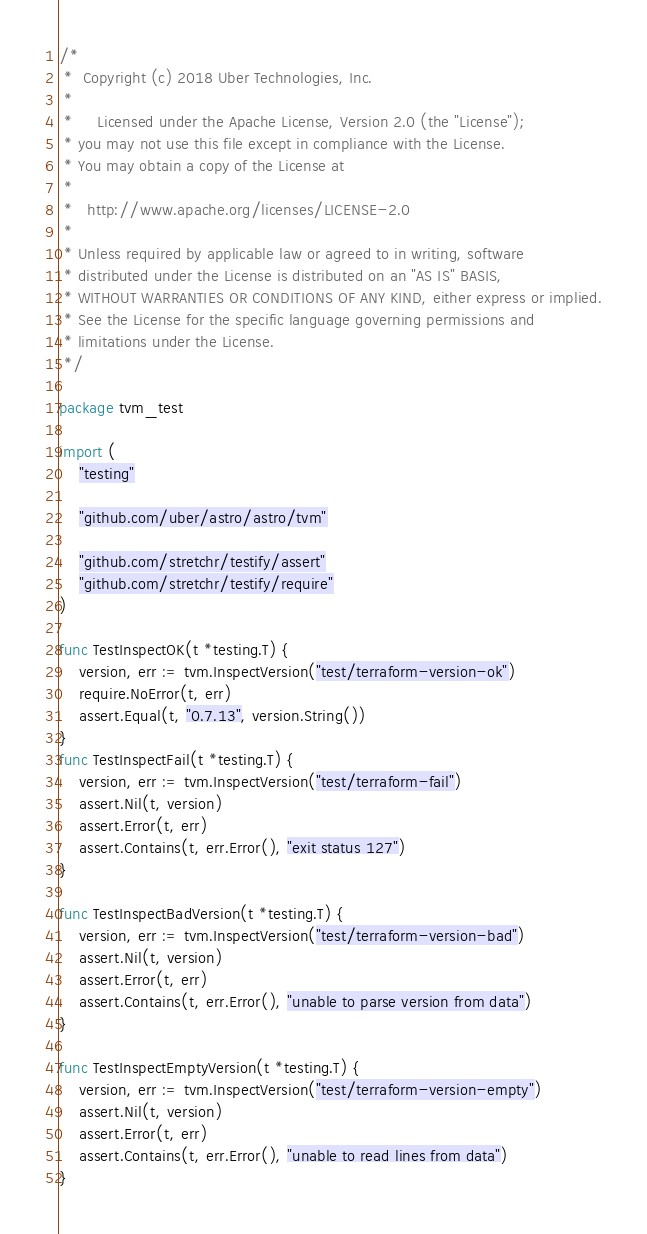<code> <loc_0><loc_0><loc_500><loc_500><_Go_>/*
 *  Copyright (c) 2018 Uber Technologies, Inc.
 *
 *     Licensed under the Apache License, Version 2.0 (the "License");
 * you may not use this file except in compliance with the License.
 * You may obtain a copy of the License at
 *
 *   http://www.apache.org/licenses/LICENSE-2.0
 *
 * Unless required by applicable law or agreed to in writing, software
 * distributed under the License is distributed on an "AS IS" BASIS,
 * WITHOUT WARRANTIES OR CONDITIONS OF ANY KIND, either express or implied.
 * See the License for the specific language governing permissions and
 * limitations under the License.
 */

package tvm_test

import (
	"testing"

	"github.com/uber/astro/astro/tvm"

	"github.com/stretchr/testify/assert"
	"github.com/stretchr/testify/require"
)

func TestInspectOK(t *testing.T) {
	version, err := tvm.InspectVersion("test/terraform-version-ok")
	require.NoError(t, err)
	assert.Equal(t, "0.7.13", version.String())
}
func TestInspectFail(t *testing.T) {
	version, err := tvm.InspectVersion("test/terraform-fail")
	assert.Nil(t, version)
	assert.Error(t, err)
	assert.Contains(t, err.Error(), "exit status 127")
}

func TestInspectBadVersion(t *testing.T) {
	version, err := tvm.InspectVersion("test/terraform-version-bad")
	assert.Nil(t, version)
	assert.Error(t, err)
	assert.Contains(t, err.Error(), "unable to parse version from data")
}

func TestInspectEmptyVersion(t *testing.T) {
	version, err := tvm.InspectVersion("test/terraform-version-empty")
	assert.Nil(t, version)
	assert.Error(t, err)
	assert.Contains(t, err.Error(), "unable to read lines from data")
}
</code> 